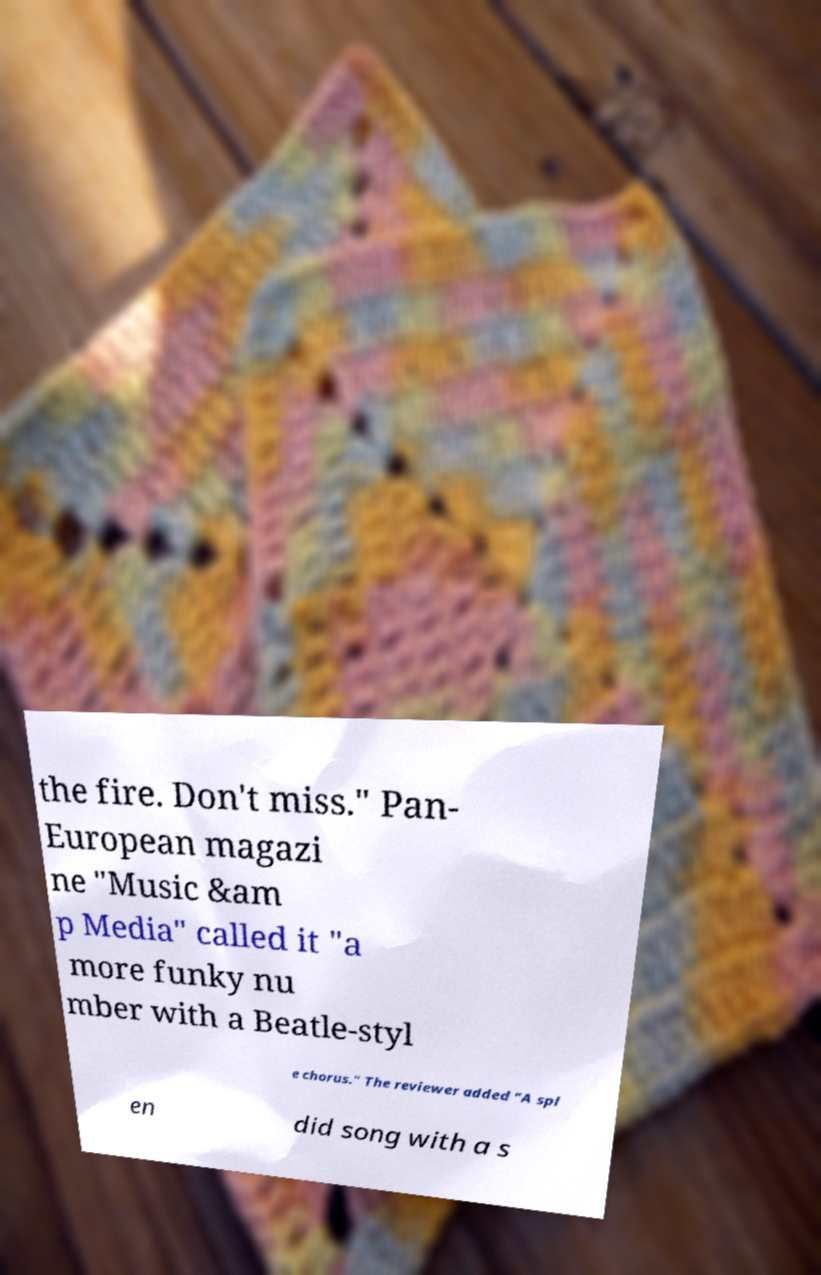Please read and relay the text visible in this image. What does it say? the fire. Don't miss." Pan- European magazi ne "Music &am p Media" called it "a more funky nu mber with a Beatle-styl e chorus." The reviewer added "A spl en did song with a s 